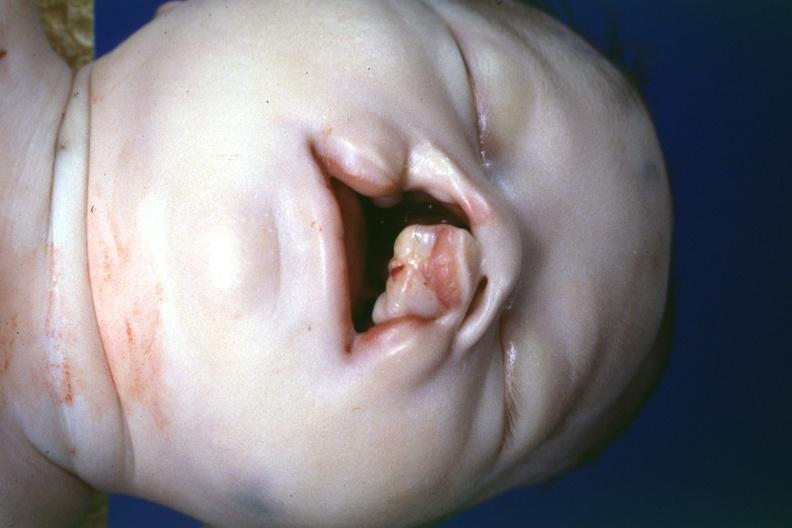what is present?
Answer the question using a single word or phrase. Face 